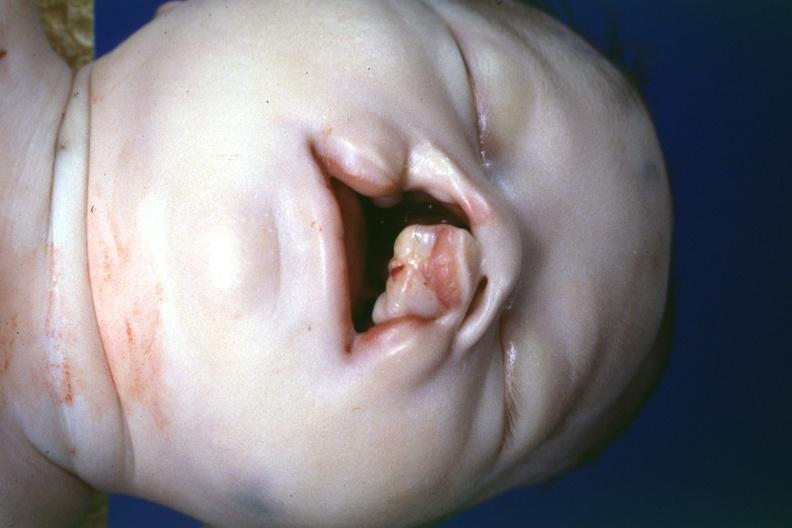what is present?
Answer the question using a single word or phrase. Face 